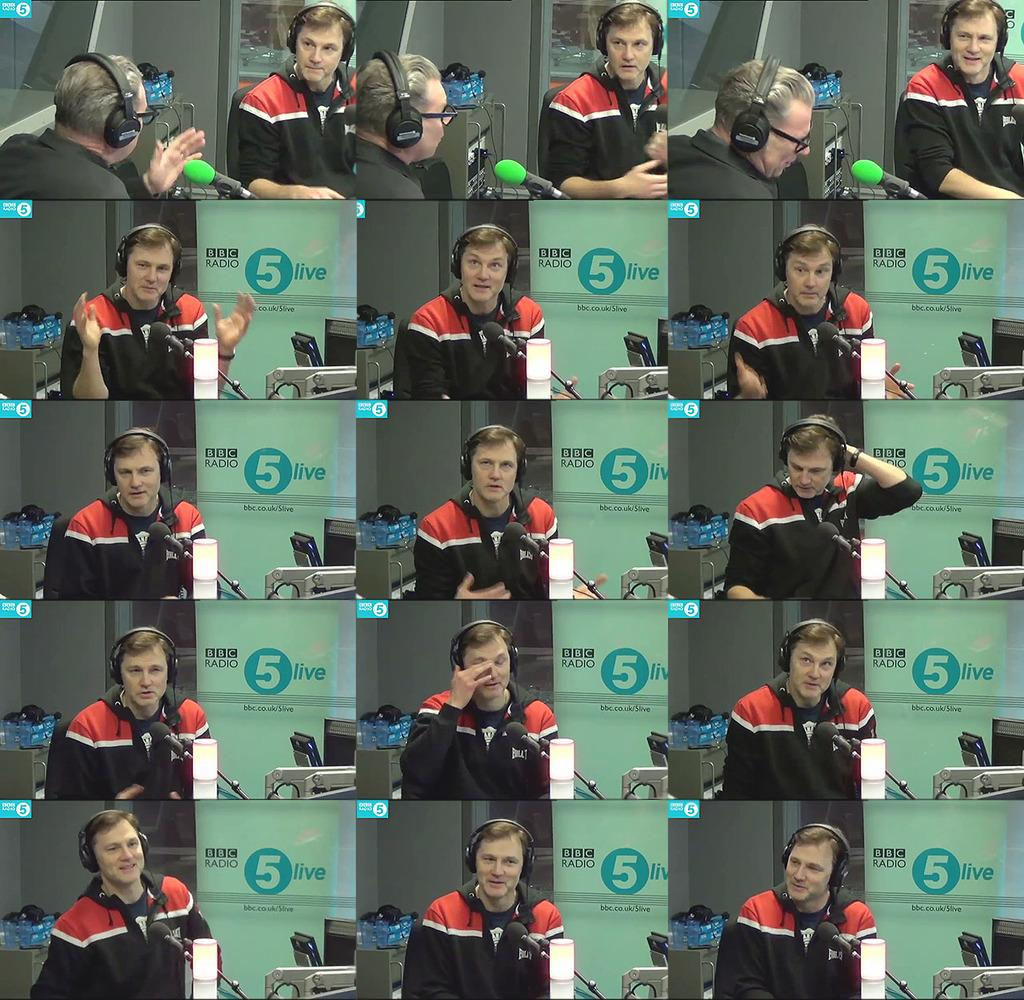What type of image is shown in the picture? The image is a photo collage. Can you describe the person in the image? There is a man in the image. What is the man wearing on his head? The man is wearing a headset. What color is the man's t-shirt? The man is wearing a black color t-shirt. What scale is used to measure the man's height in the image? The image does not include any scale for measuring the man's height. 